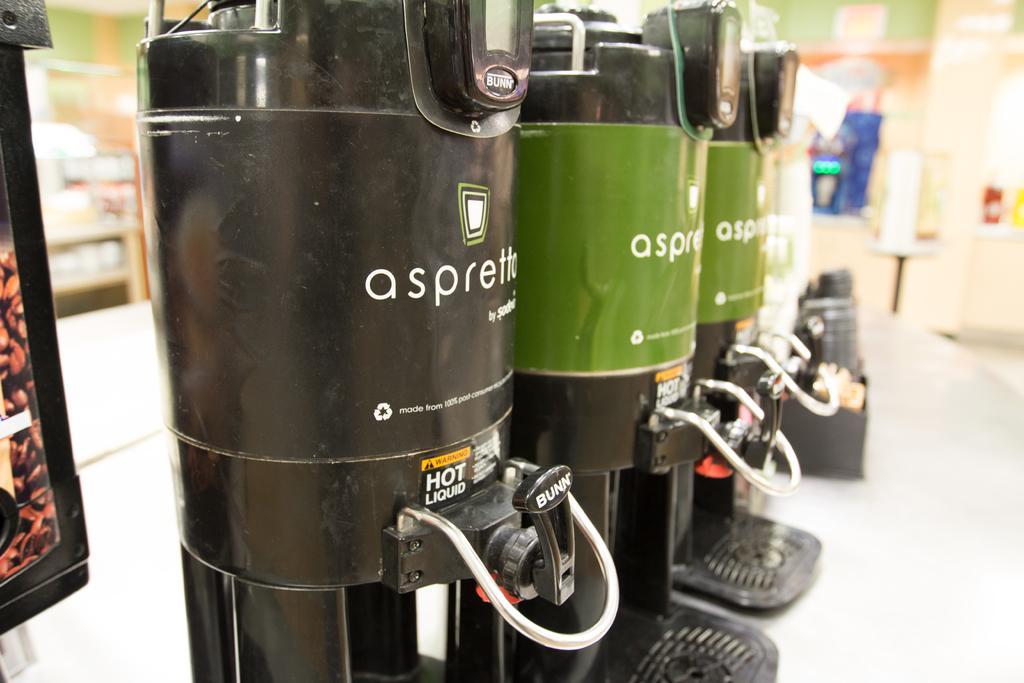How would you summarize this image in a sentence or two? This image consists of machines. They look like coffee machine kept in a line. At the bottom, there is a table. It looks like a coffee shop. 